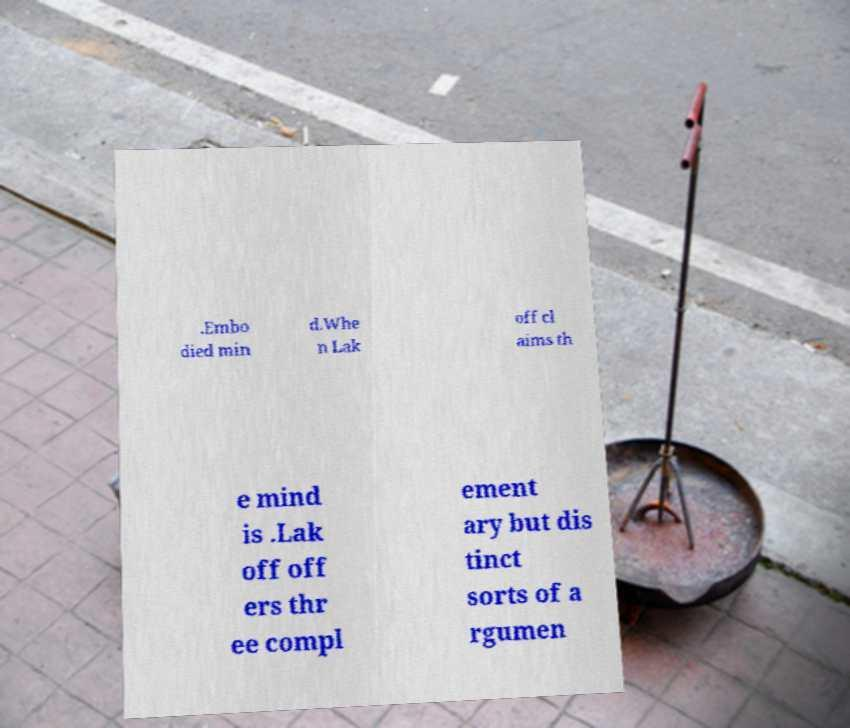Can you accurately transcribe the text from the provided image for me? .Embo died min d.Whe n Lak off cl aims th e mind is .Lak off off ers thr ee compl ement ary but dis tinct sorts of a rgumen 